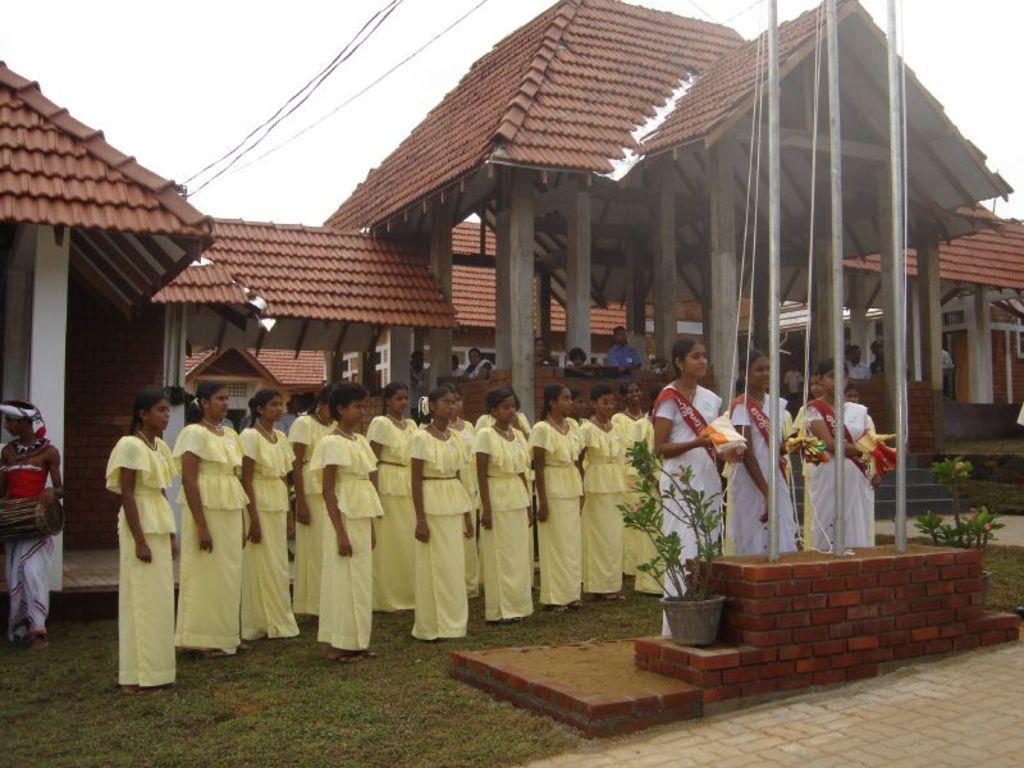In one or two sentences, can you explain what this image depicts? In this image we can see few persons are standing on the grass. On the left side a person is holding a musical instrument in the hands. There are three women standing at the poles and among them few persons are holding objects in their hands and we can see ropes, plants in the pots on the platform. In the background we can see a pillars, walls, roofs and sky. 